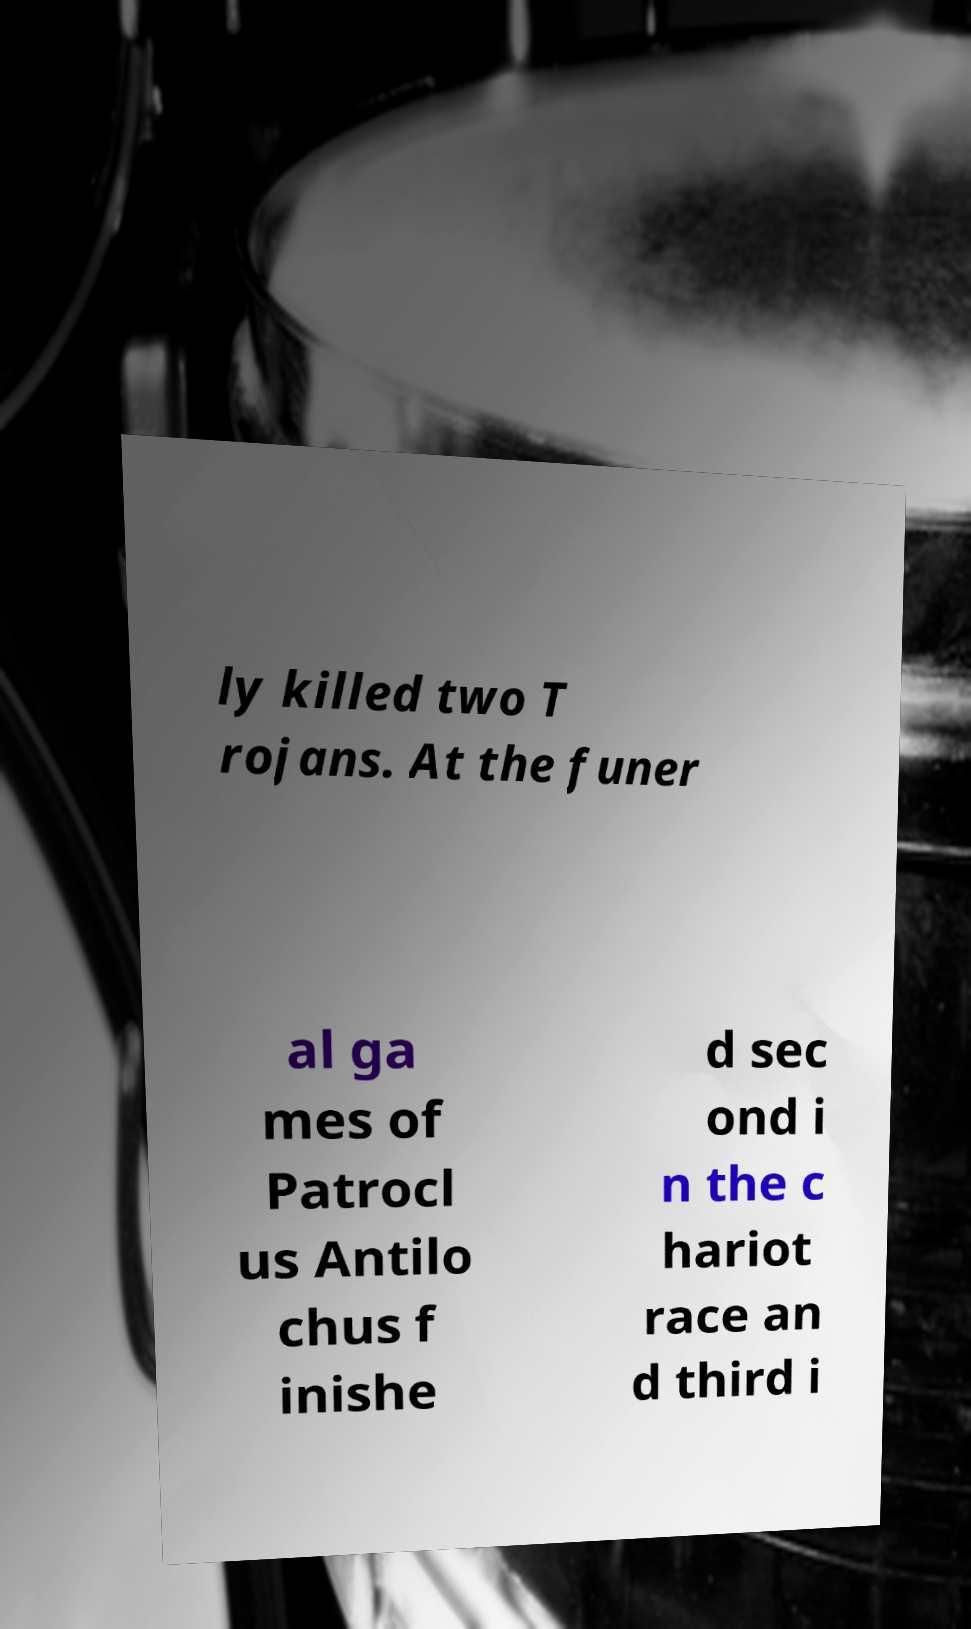What messages or text are displayed in this image? I need them in a readable, typed format. ly killed two T rojans. At the funer al ga mes of Patrocl us Antilo chus f inishe d sec ond i n the c hariot race an d third i 